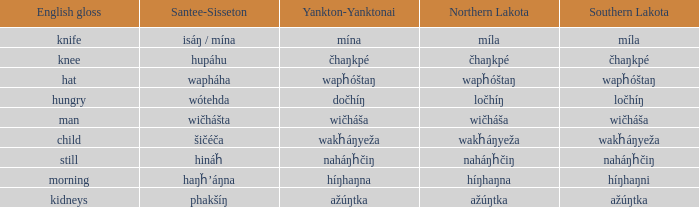Help me parse the entirety of this table. {'header': ['English gloss', 'Santee-Sisseton', 'Yankton-Yanktonai', 'Northern Lakota', 'Southern Lakota'], 'rows': [['knife', 'isáŋ / mína', 'mína', 'míla', 'míla'], ['knee', 'hupáhu', 'čhaŋkpé', 'čhaŋkpé', 'čhaŋkpé'], ['hat', 'wapháha', 'wapȟóštaŋ', 'wapȟóštaŋ', 'wapȟóštaŋ'], ['hungry', 'wótehda', 'dočhíŋ', 'ločhíŋ', 'ločhíŋ'], ['man', 'wičhášta', 'wičháša', 'wičháša', 'wičháša'], ['child', 'šičéča', 'wakȟáŋyeža', 'wakȟáŋyeža', 'wakȟáŋyeža'], ['still', 'hináȟ', 'naháŋȟčiŋ', 'naháŋȟčiŋ', 'naháŋȟčiŋ'], ['morning', 'haŋȟ’áŋna', 'híŋhaŋna', 'híŋhaŋna', 'híŋhaŋni'], ['kidneys', 'phakšíŋ', 'ažúŋtka', 'ažúŋtka', 'ažúŋtka']]} Name the southern lakota for híŋhaŋna Híŋhaŋni. 